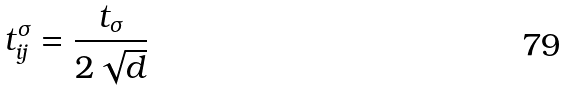<formula> <loc_0><loc_0><loc_500><loc_500>t ^ { \sigma } _ { i j } = \frac { t _ { \sigma } } { 2 \sqrt { d } }</formula> 